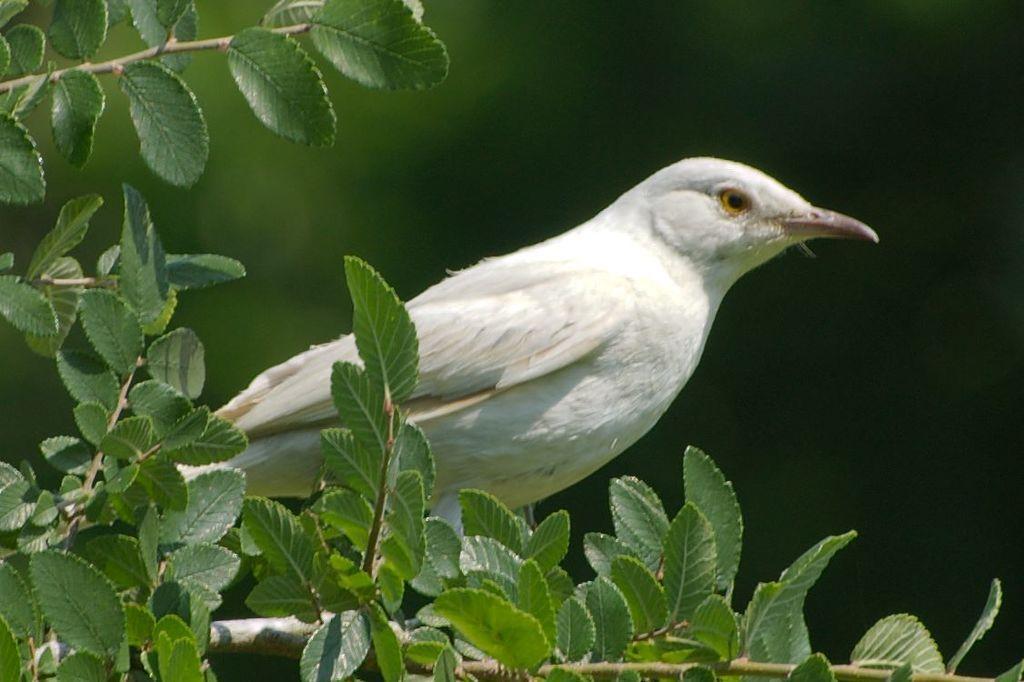Could you give a brief overview of what you see in this image? In this image, there are some green color leaves, there is a white color sitting on the plant. 